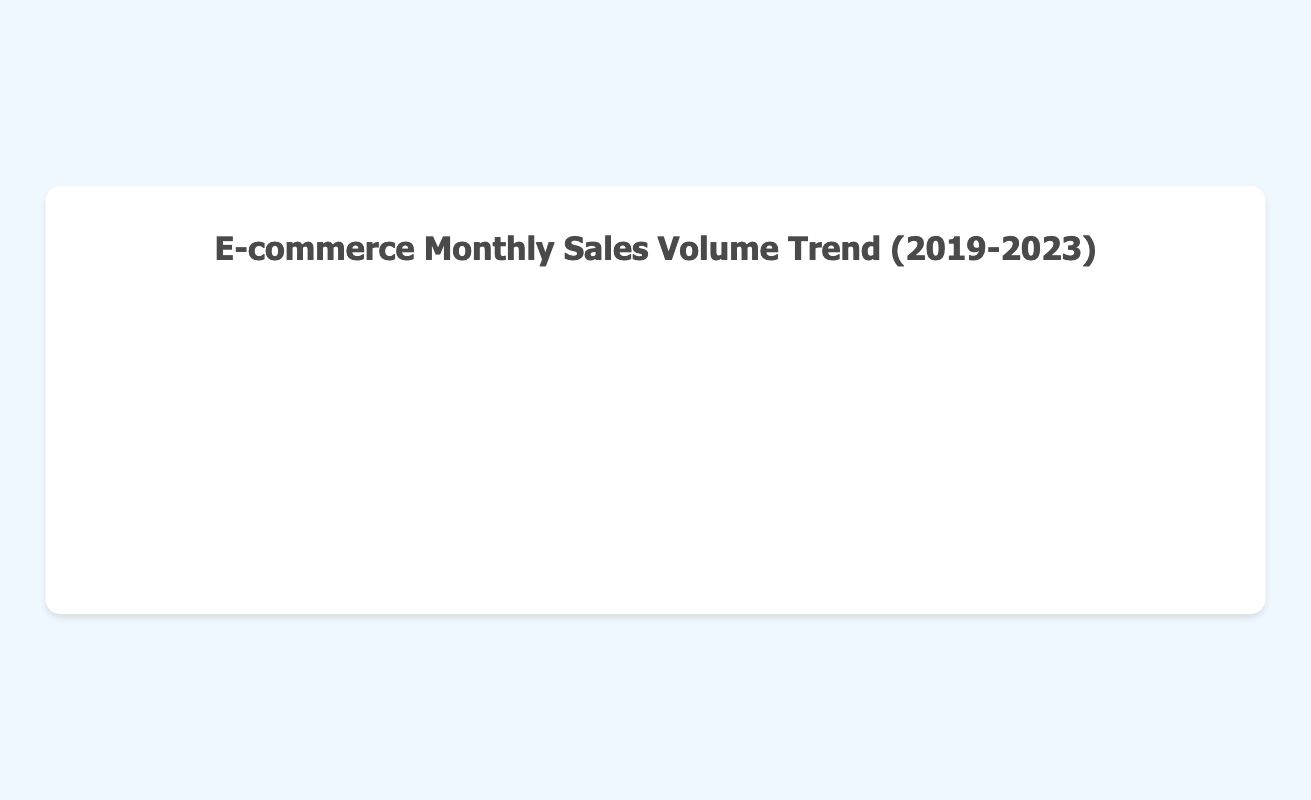What is the total sales volume for the entire year of 2021? To find the total sales volume for 2021, sum the sales volumes from January to December 2021: 350,000 + 370,000 + 385,000 + 400,000 + 415,000 + 430,000 + 450,000 + 465,000 + 480,000 + 500,000 + 520,000 + 550,000 = 5,315,000
Answer: 5,315,000 How does the sales volume in December 2023 compare to December 2022? Compare the sales volumes for December 2023 and December 2022: December 2023 is 700,000, and December 2022 is 600,000. The sales volume in December 2023 is higher than December 2022 by 100,000.
Answer: 100,000 higher Which year had the highest sales volume in December? Look at the sales volumes for December in each year: 2019 (450,000), 2020 (500,000), 2021 (550,000), 2022 (600,000), and 2023 (700,000). December 2023 had the highest sales volume.
Answer: 2023 What is the average monthly sales volume for the year 2020? To find the average monthly sales volume for 2020, sum the sales volumes for January to December 2020 and divide by 12: (310,000 + 325,000 + 340,000 + 355,000 + 370,000 + 385,000 + 400,000 + 420,000 + 440,000 + 460,000 + 480,000 + 500,000) / 12 = 430,000
Answer: 430,000 In which month was the sales volume the highest in 2022, and what was the value? Identify the highest sales volume month in 2022 by examining all months: 400,000 (Jan), 415,000 (Feb), 430,000 (Mar), 445,000 (Apr), 460,000 (May), 480,000 (Jun), 495,000 (Jul), 510,000 (Aug), 530,000 (Sep), 550,000 (Oct), 570,000 (Nov), 600,000 (Dec). The highest was in December 2022 with 600,000.
Answer: December 2022, 600,000 How much did the sales volume increase from January to December 2021? Subtract the sales volume of January 2021 from December 2021: 550,000 (Dec) - 350,000 (Jan) = 200,000
Answer: 200,000 Did the sales volume increase or decrease from July 2020 to August 2020, and by how much? Compare the sales volumes between July 2020 (400,000) and August 2020 (420,000): 420,000 - 400,000 = 20,000. The sales volume increased by 20,000.
Answer: Increased by 20,000 What is the trend of the sales volume from January to December 2023? Examine the sales volumes from January to December 2023: 450,000, 470,000, 490,000, 505,000, 520,000, 540,000, 565,000, 580,000, 600,000, 620,000, 640,000, 700,000. The trend is consistently increasing each month.
Answer: Increasing trend By how much did the sales volume in September 2020 differ from September 2023? Subtract the sales volume of September 2020 from September 2023: 600,000 (Sep 2023) - 440,000 (Sep 2020) = 160,000
Answer: 160,000 What is the difference in sales volume between the highest and lowest months in 2019? Identify the highest and lowest sales volumes in 2019: highest is 450,000 (Dec) and lowest is 270,000 (Jan). Difference: 450,000 - 270,000 = 180,000
Answer: 180,000 